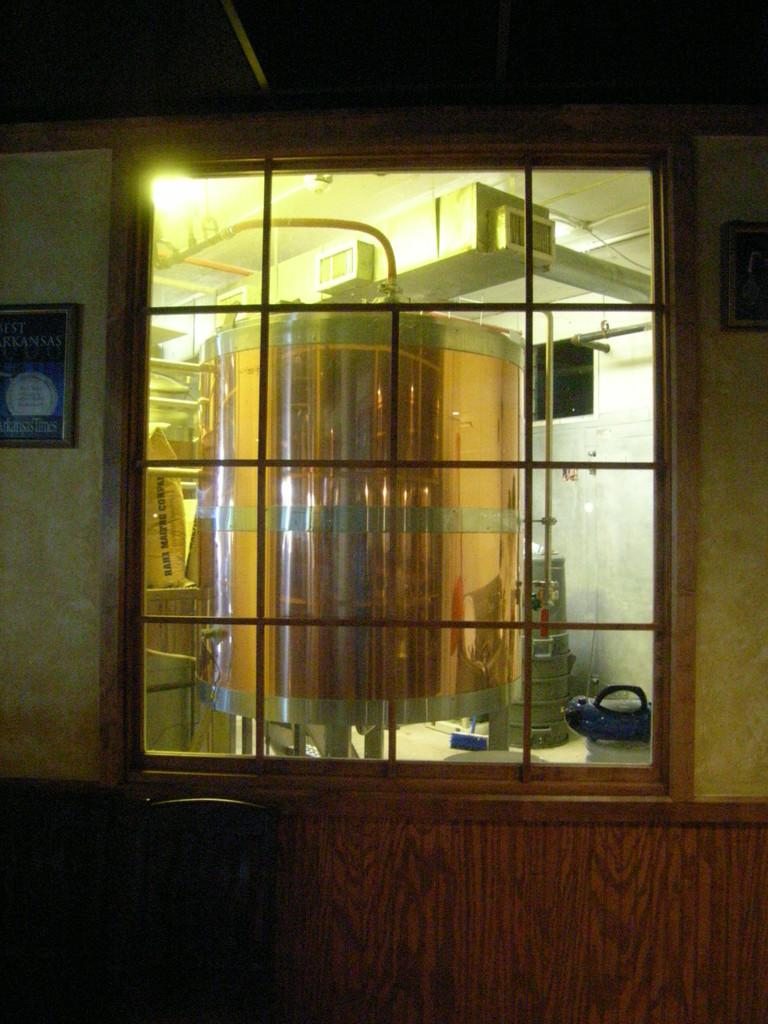What type of structure is present in the image? There is a glass window in the image. What can be seen on the wall near the glass window? There are photo frames on the wall in the image. What is located behind the glass window? There is a machine behind the glass window. Can you describe the lighting conditions in the image? There is light visible in the image. What else can be seen behind the glass window? There are some objects behind the glass window. Can you see any dirt on the garden in the image? There is no garden present in the image, so it is not possible to see any dirt on it. 